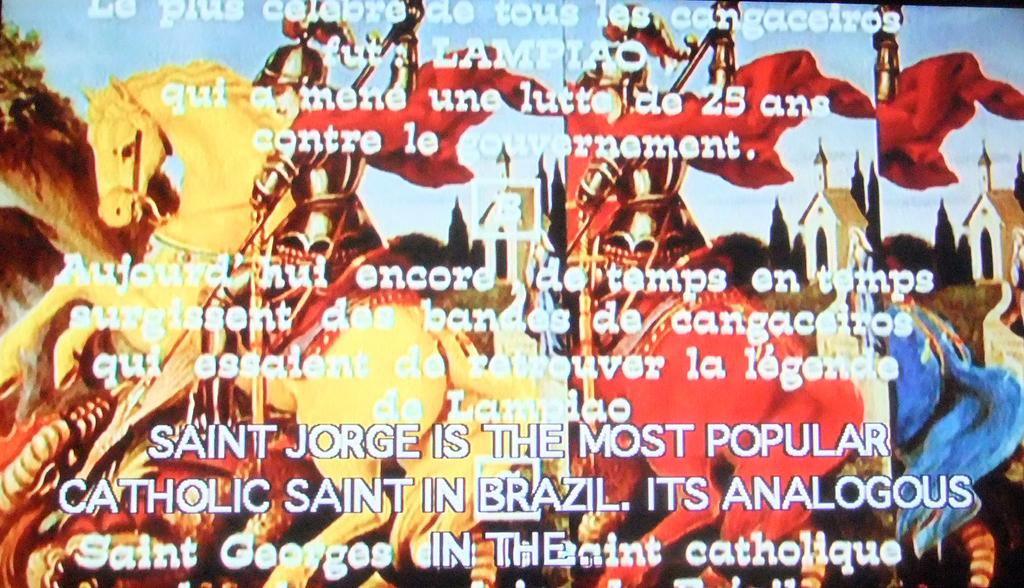<image>
Summarize the visual content of the image. Three colorful horses with a caption about  "Saint Jorge" in front of them. 